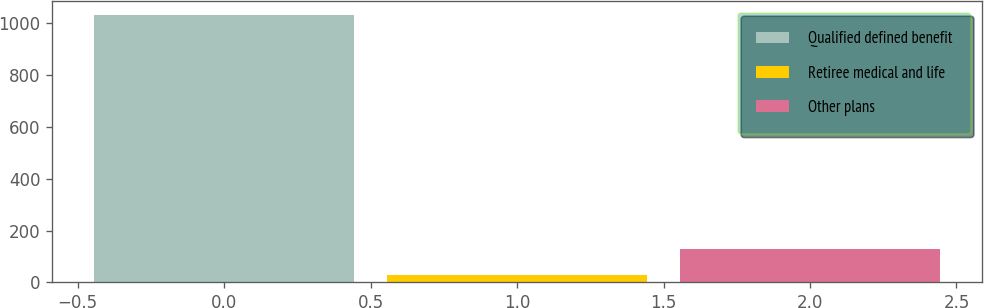Convert chart. <chart><loc_0><loc_0><loc_500><loc_500><bar_chart><fcel>Qualified defined benefit<fcel>Retiree medical and life<fcel>Other plans<nl><fcel>1034<fcel>28<fcel>128.6<nl></chart> 